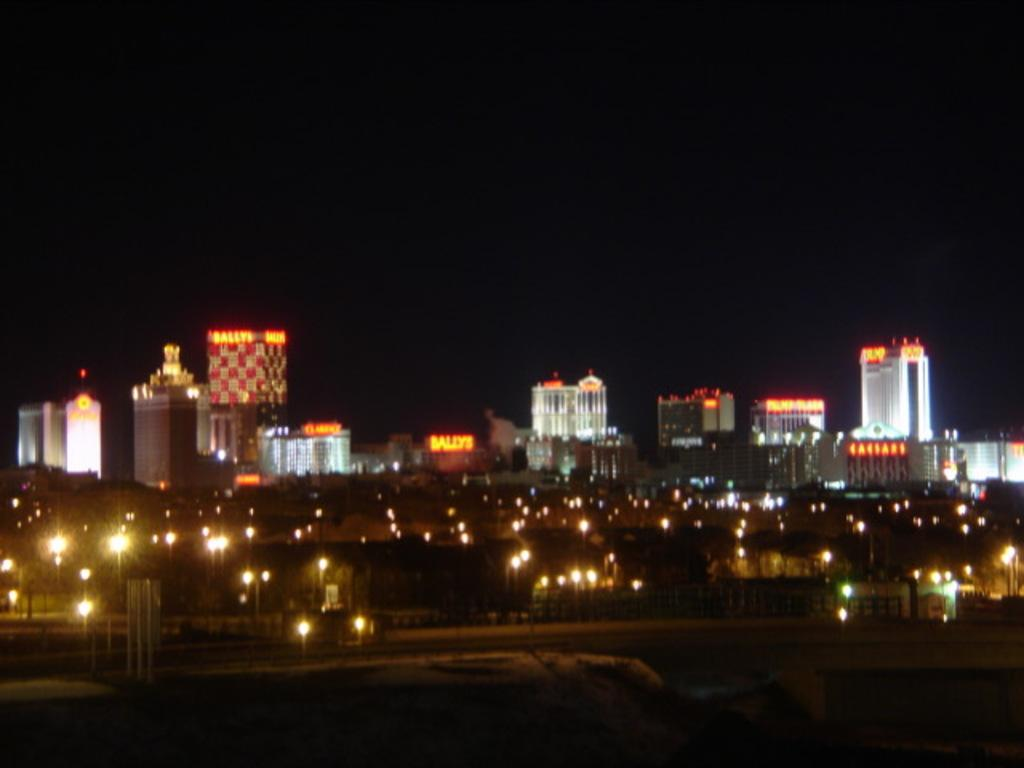What type of structures can be seen in the image? There are buildings in the image. What else can be seen on the ground in the image? There is a road in the image. What type of lighting is present along the road? Street lights are visible in the image. What is visible above the buildings and road in the image? The sky is visible in the image. Can you tell me what book the bear is holding in the image? There is no book or bear present in the image. 